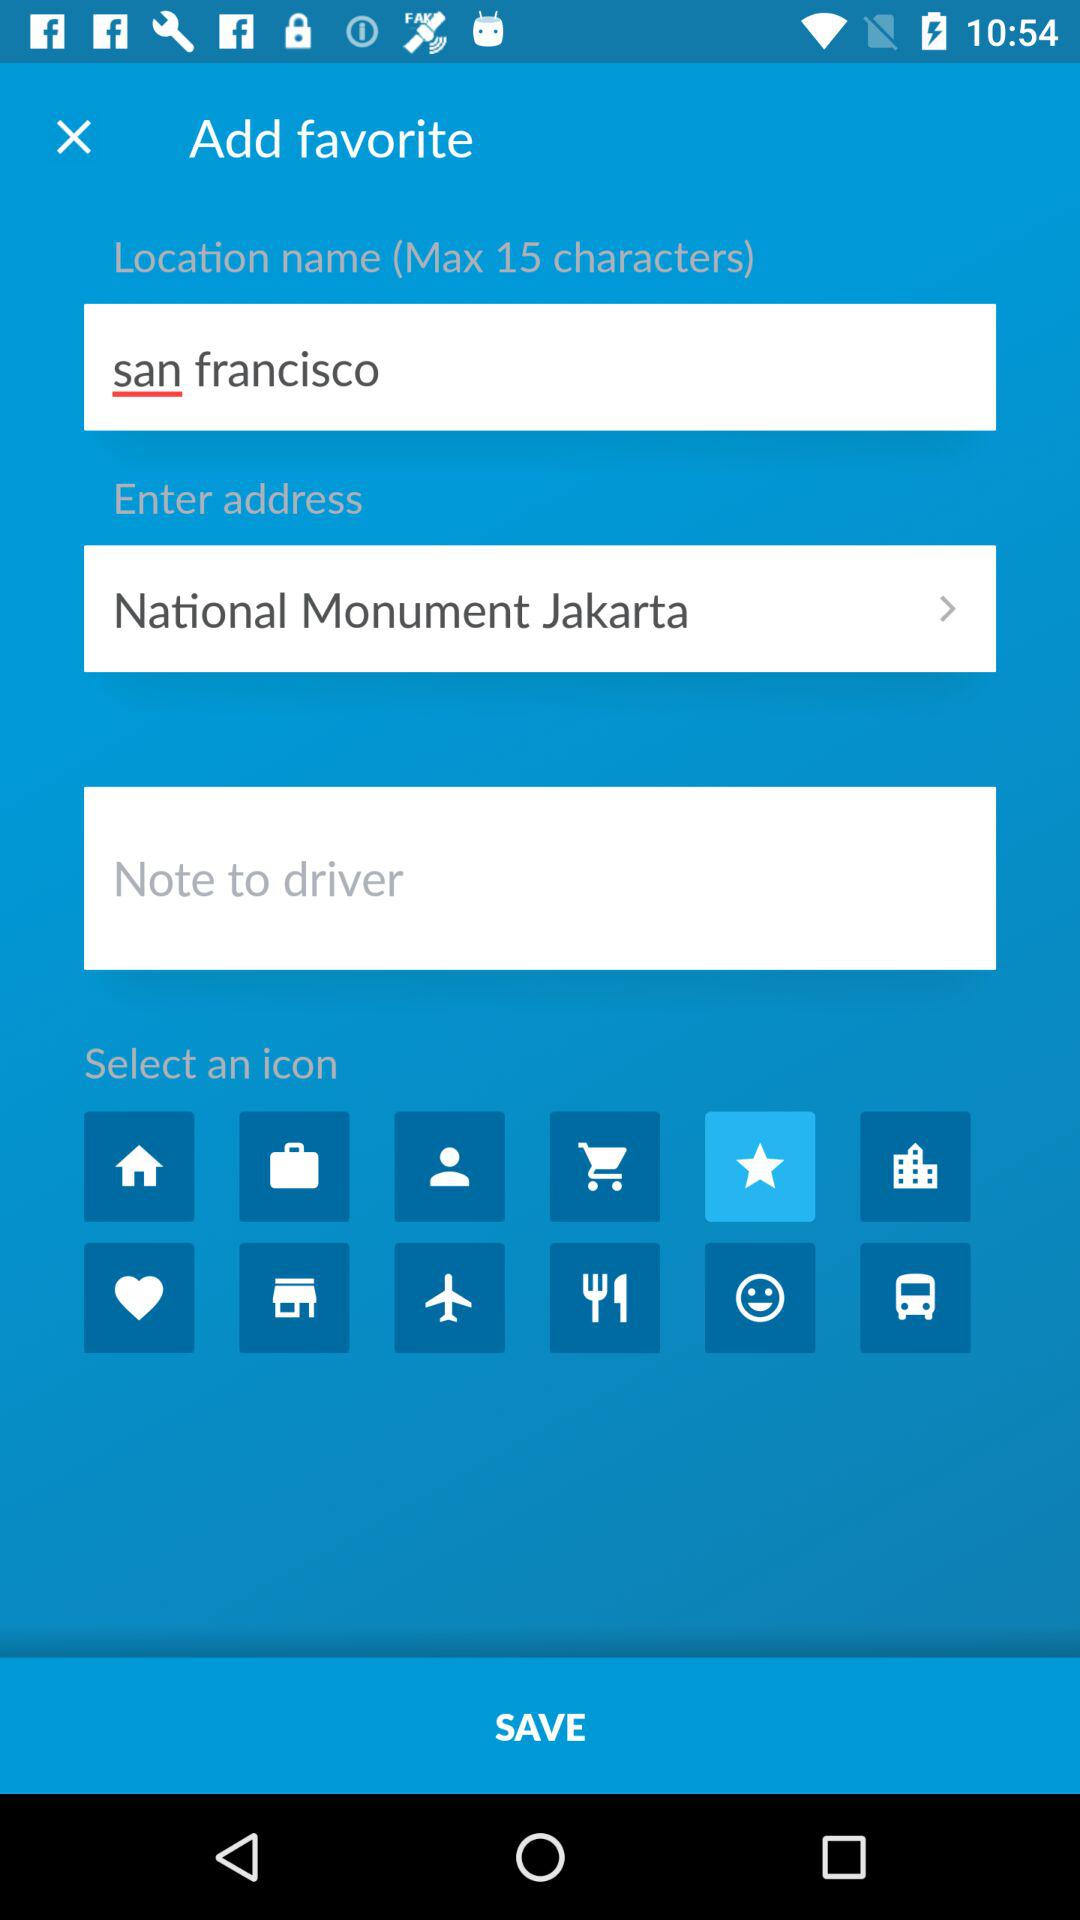What is written in the "Enter address" field? In the "Enter address" field, "National Monument Jakarta" is written. 